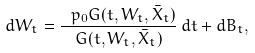Convert formula to latex. <formula><loc_0><loc_0><loc_500><loc_500>d W _ { t } = \frac { \ p _ { 0 } G ( t , W _ { t } , \bar { X } _ { t } ) } { G ( t , W _ { t } , \bar { X } _ { t } ) } \, d t + d B _ { t } ,</formula> 